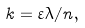Convert formula to latex. <formula><loc_0><loc_0><loc_500><loc_500>k = \varepsilon \lambda / n ,</formula> 